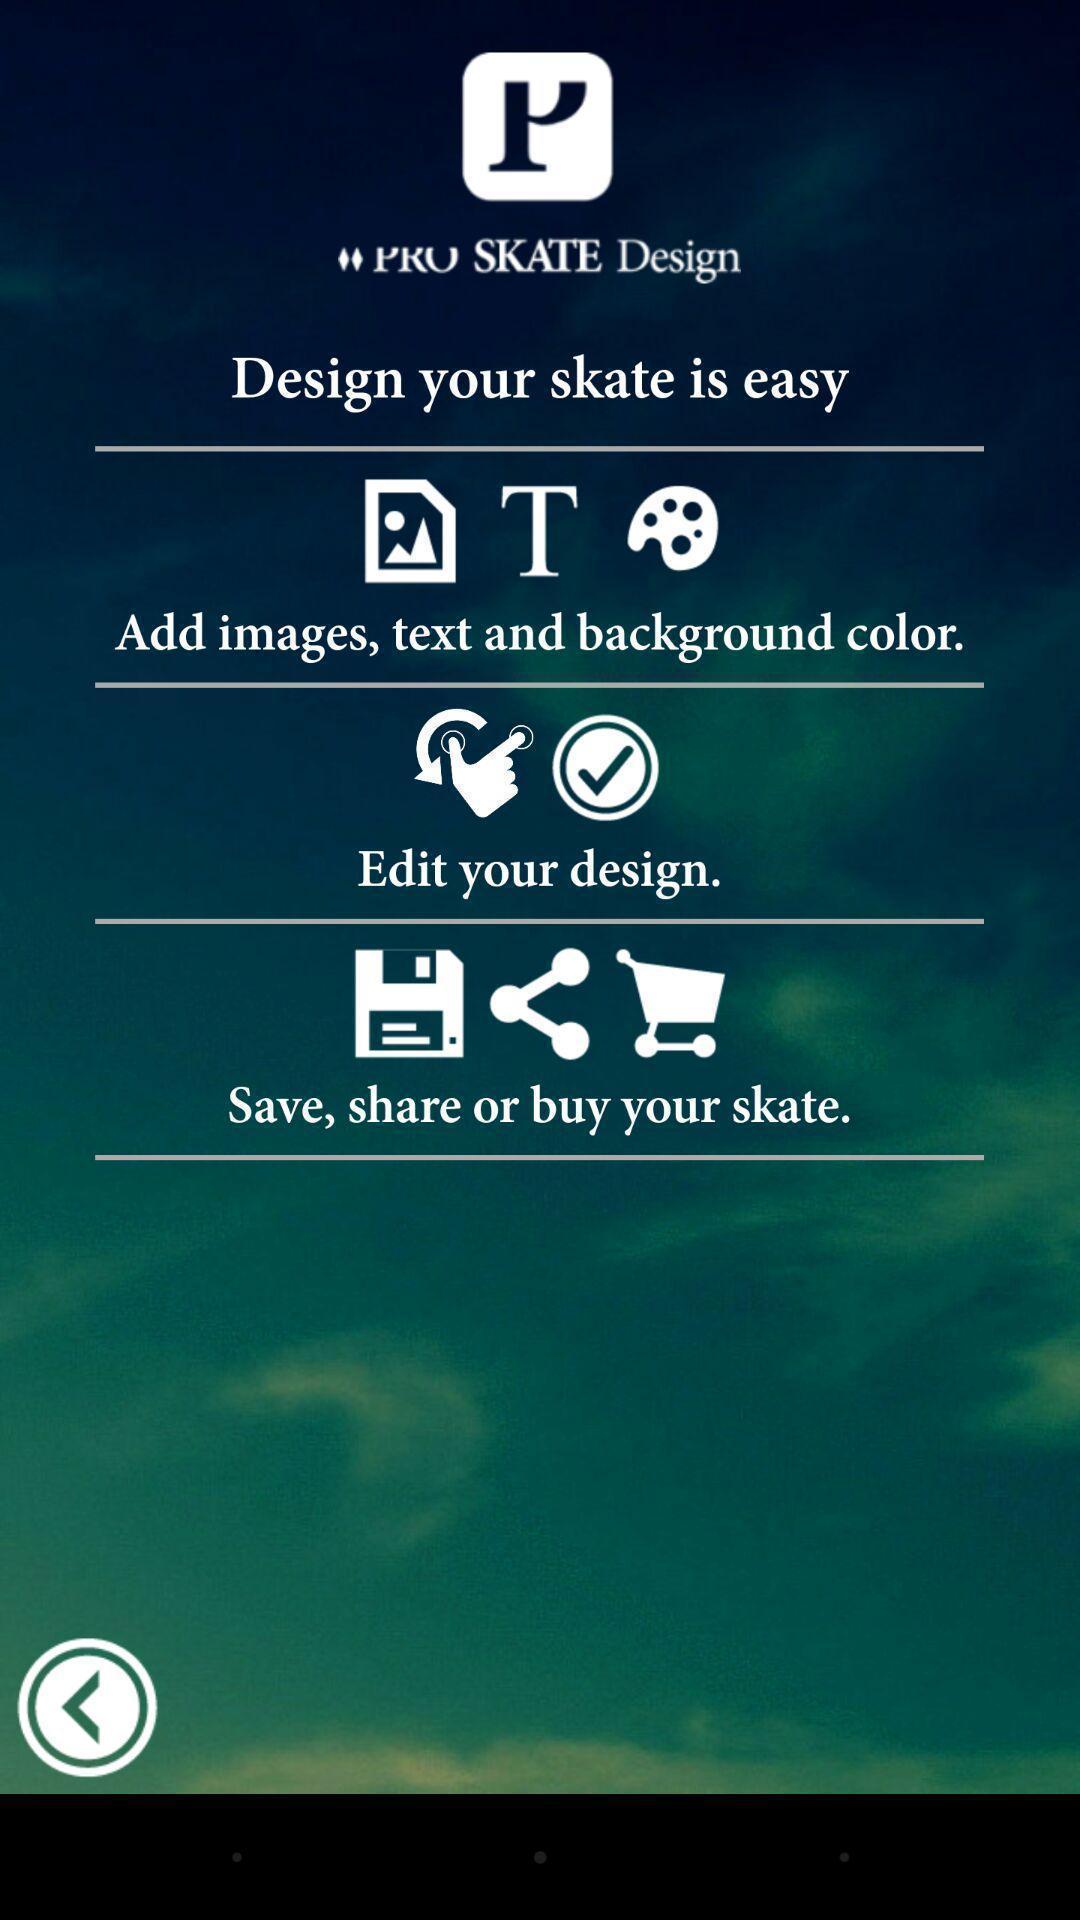Describe the key features of this screenshot. Window displaying a skateboard app. 